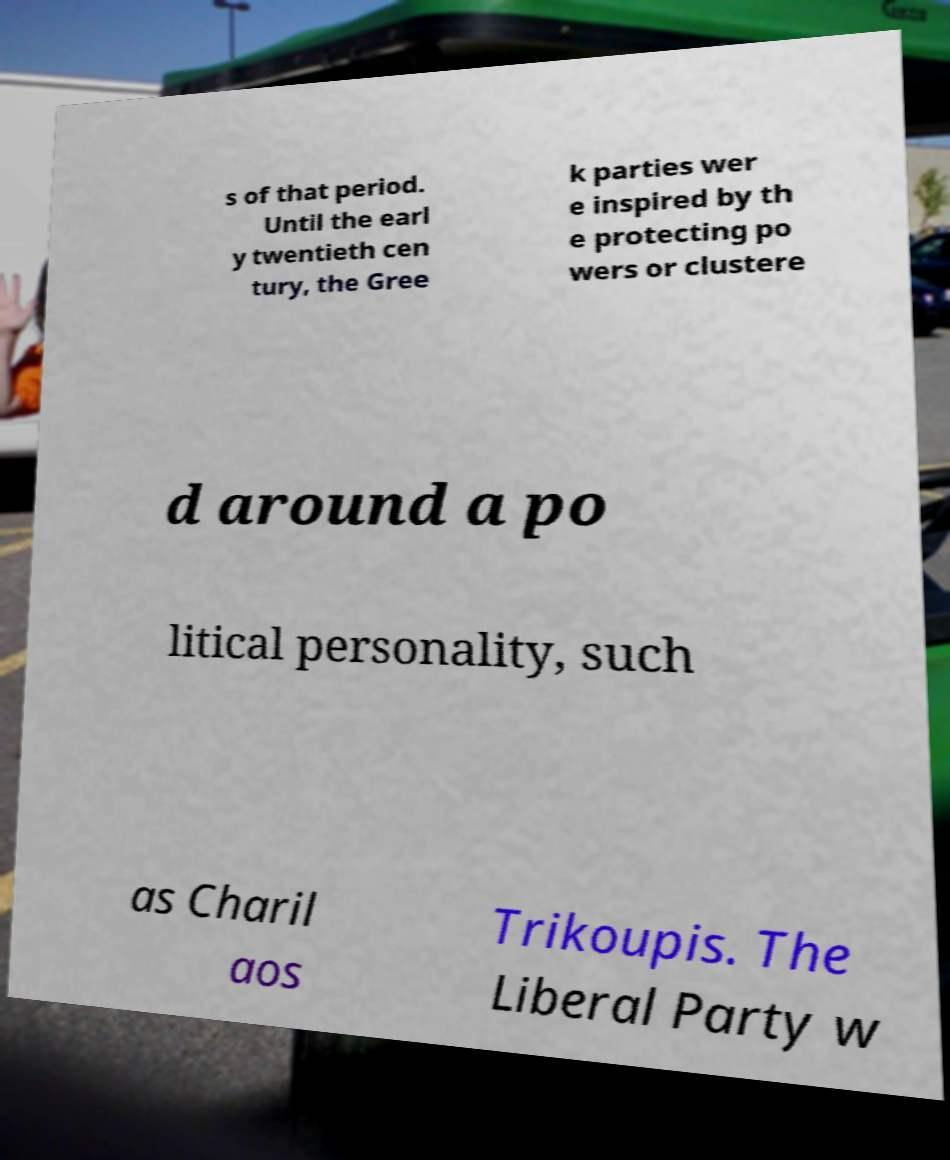For documentation purposes, I need the text within this image transcribed. Could you provide that? s of that period. Until the earl y twentieth cen tury, the Gree k parties wer e inspired by th e protecting po wers or clustere d around a po litical personality, such as Charil aos Trikoupis. The Liberal Party w 